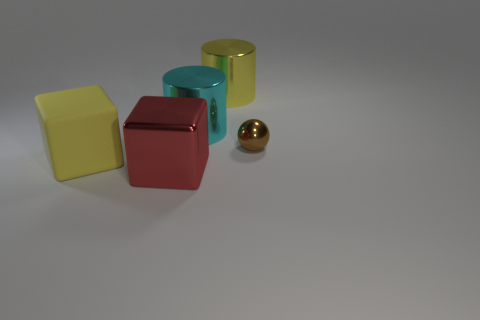Subtract all balls. How many objects are left? 4 Add 4 rubber objects. How many objects exist? 9 Subtract 2 cylinders. How many cylinders are left? 0 Subtract all gray cylinders. Subtract all brown blocks. How many cylinders are left? 2 Subtract all blue blocks. How many blue balls are left? 0 Subtract all big metallic objects. Subtract all cyan spheres. How many objects are left? 2 Add 2 yellow matte cubes. How many yellow matte cubes are left? 3 Add 3 small metallic cubes. How many small metallic cubes exist? 3 Subtract 0 gray balls. How many objects are left? 5 